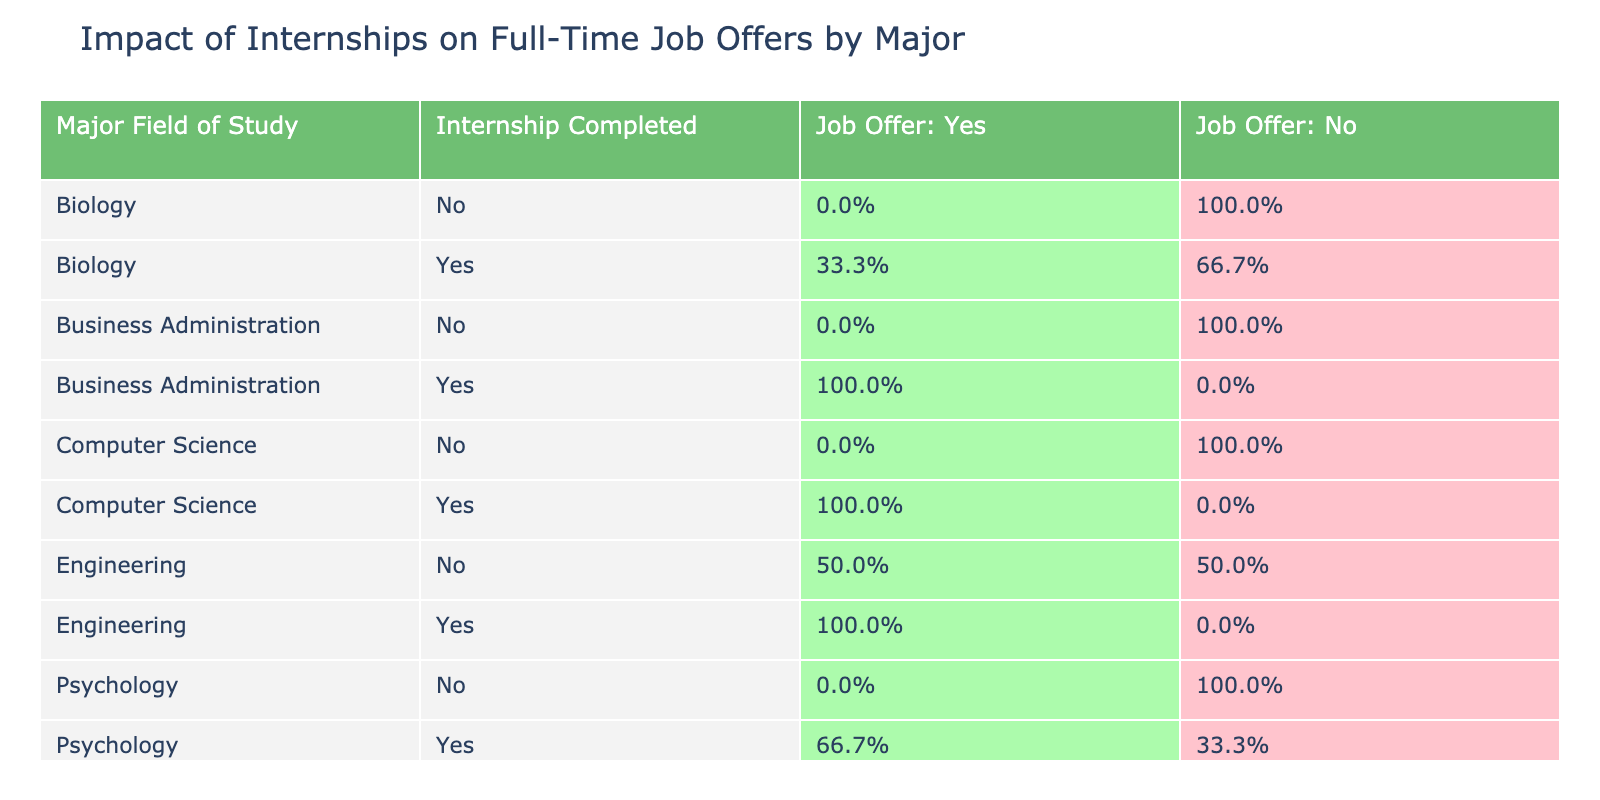What percentage of Computer Science majors who completed internships received job offers? From the table, for Computer Science majors who completed internships, 100% received job offers (2 Yes out of 2).
Answer: 100% What is the percentage of Engineering majors who did not complete internships and received job offers? From the table, for Engineering majors who did not complete internships, 50% received job offers (1 Yes out of 2).
Answer: 50% Did any Biology majors who completed internships receive job offers? Yes, there is one Biology major who completed an internship and received a job offer.
Answer: Yes What is the total percentage of Business Administration majors who received job offers? For Business Administration, there are four Yes and three No, so total job offers = 4/(4+3) = 4/7, which is approximately 57.1%.
Answer: 57.1% Which major field of study has the highest percentage of job offers received by those who completed internships? Looking at the data, Engineering has a 100% success rate for those who completed internships (4 Yes out of 4).
Answer: Engineering What is the difference in percentage of job offers received between Computer Science majors who completed internships and those who did not? Computer Science majors who completed internships received 100% job offers while those who did not received 0%, hence the difference is 100%.
Answer: 100% How many Psychology majors did not receive job offers regardless of internship completion? There are three Psychology majors who did not receive job offers (2 with no internships and 1 who completed an internship).
Answer: 3 What percentage of Biology majors who completed internships received job offers? Among Biology majors who completed internships, only one out of three received a job offer, making it approximately 33.3%.
Answer: 33.3% Was there any major where students received job offers without having completed an internship? Yes, for Engineering, one student did not complete an internship but received a job offer.
Answer: Yes 